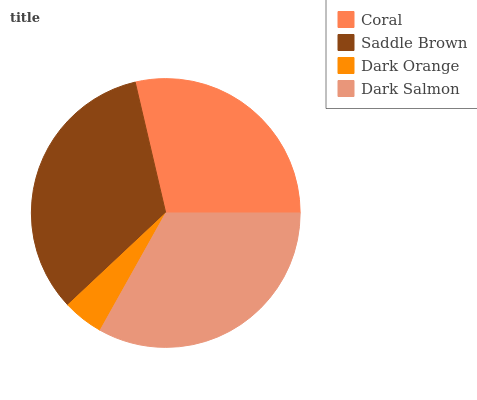Is Dark Orange the minimum?
Answer yes or no. Yes. Is Saddle Brown the maximum?
Answer yes or no. Yes. Is Saddle Brown the minimum?
Answer yes or no. No. Is Dark Orange the maximum?
Answer yes or no. No. Is Saddle Brown greater than Dark Orange?
Answer yes or no. Yes. Is Dark Orange less than Saddle Brown?
Answer yes or no. Yes. Is Dark Orange greater than Saddle Brown?
Answer yes or no. No. Is Saddle Brown less than Dark Orange?
Answer yes or no. No. Is Dark Salmon the high median?
Answer yes or no. Yes. Is Coral the low median?
Answer yes or no. Yes. Is Dark Orange the high median?
Answer yes or no. No. Is Saddle Brown the low median?
Answer yes or no. No. 